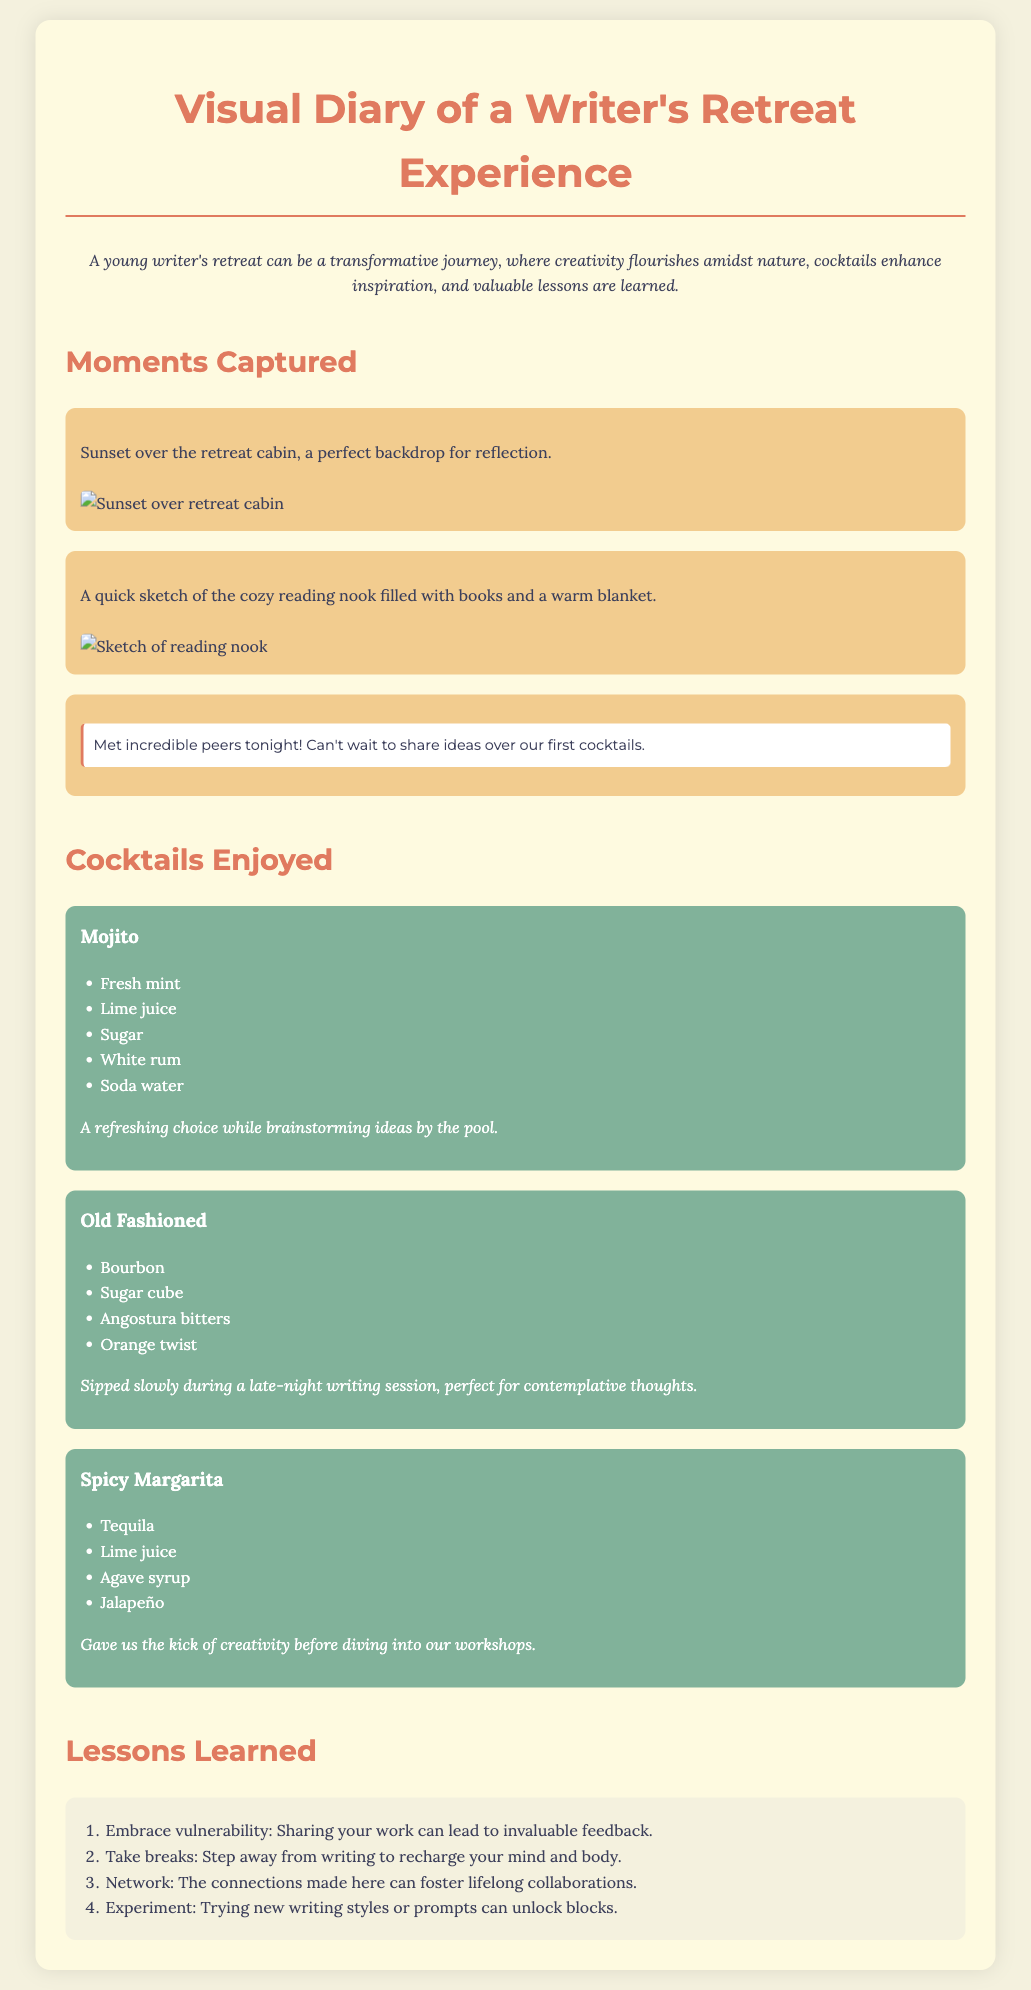What is the title of the document? The title is found at the top of the document, highlighting its main focus.
Answer: Visual Diary of a Writer's Retreat Experience How many cocktails are enjoyed in the document? The number of cocktails listed in the "Cocktails Enjoyed" section counts the variety offered.
Answer: 3 What is the first cocktail mentioned? The first cocktail is listed in the "Cocktails Enjoyed" section as the initial entry.
Answer: Mojito Which moment involves a written note? The specific moment that contains handwritten text is described in a distinct way.
Answer: Met incredible peers tonight! Can't wait to share ideas over our first cocktails What is one lesson learned related to feedback? The lessons section mentions the importance of sharing work for feedback, indicating a valuable insight.
Answer: Embrace vulnerability: Sharing your work can lead to invaluable feedback What background color is used for the container? The container's background color can be observed within the CSS styles specified in the document.
Answer: #fefae0 What type of drink is the Spicy Margarita? This drink fits the category of cocktails specifically mentioned in the document.
Answer: Cocktail What is the main theme of the visual diary? The main theme is summarized in the introductory paragraph that describes the overall experience of the retreat.
Answer: A young writer's retreat can be a transformative journey 